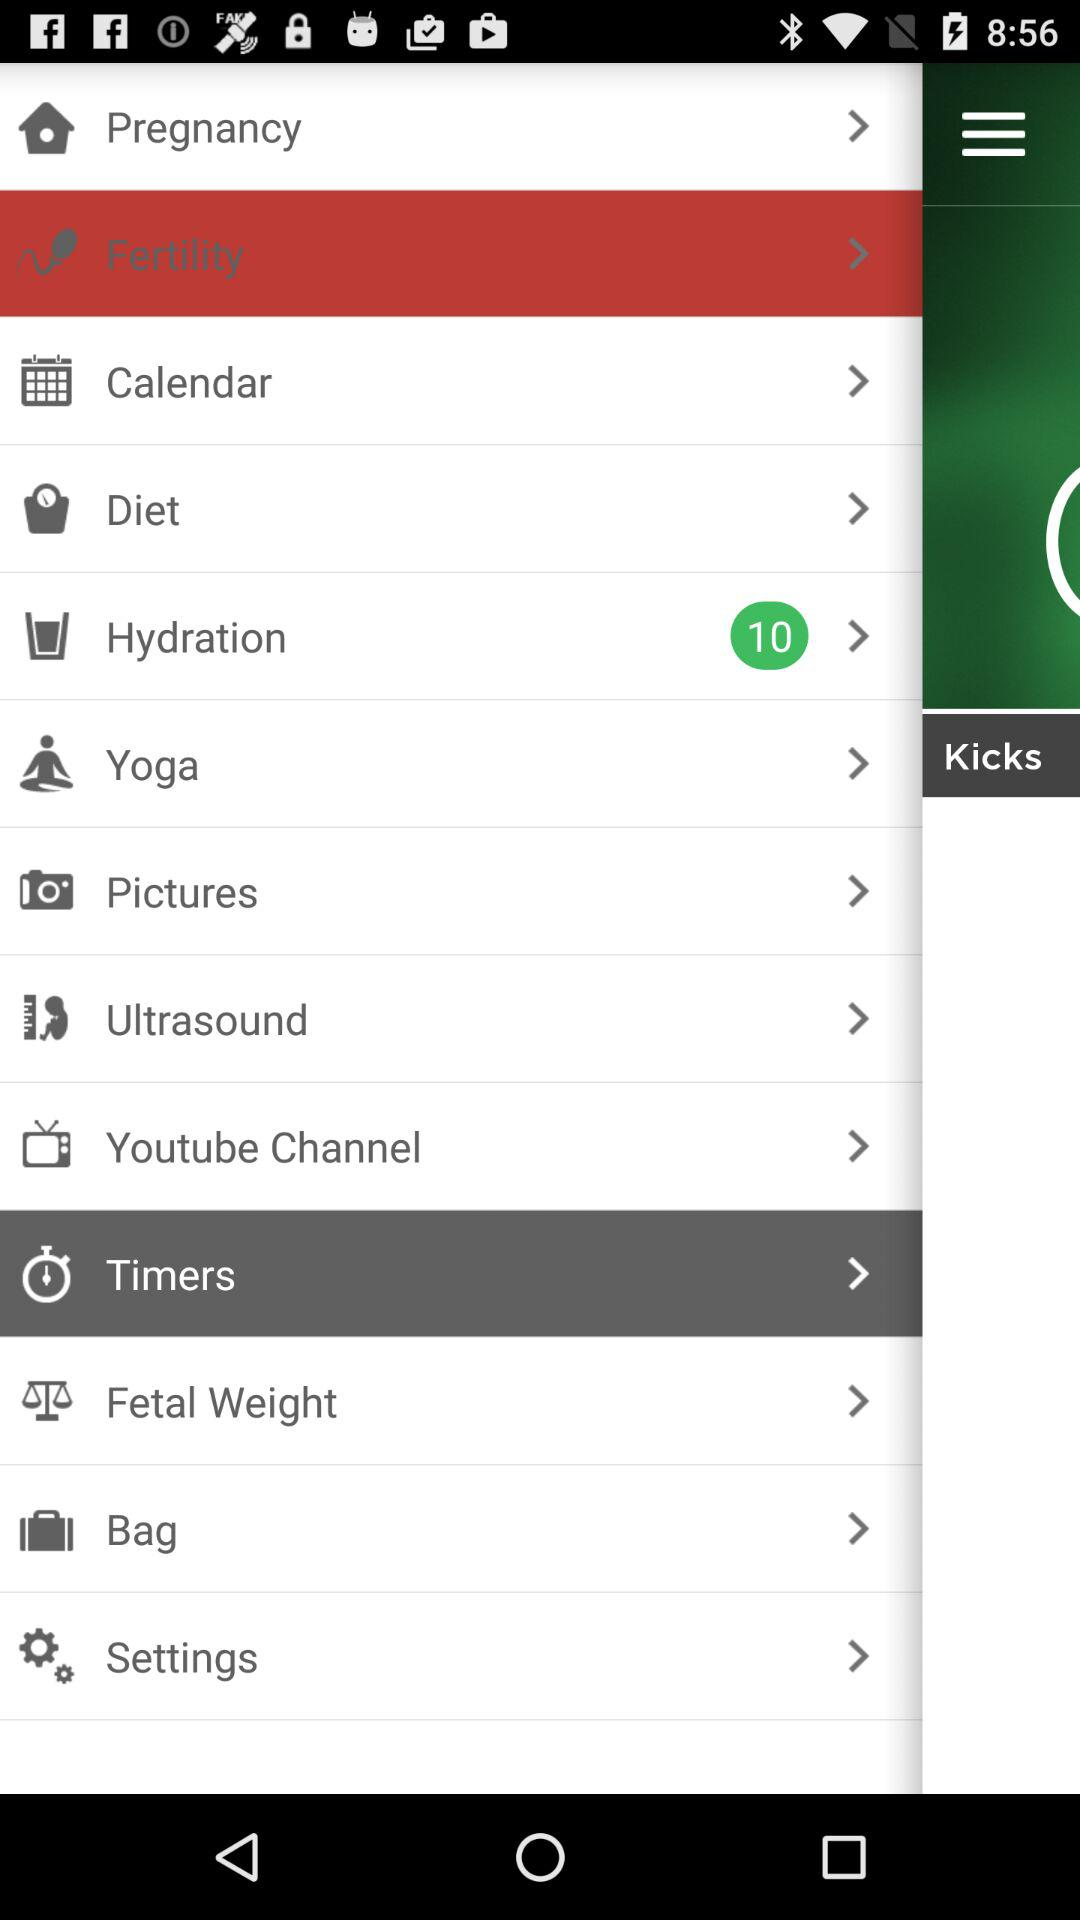How many messages are unread in "Hydration"? The number of unread messages is 10. 